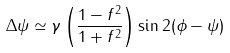Convert formula to latex. <formula><loc_0><loc_0><loc_500><loc_500>\Delta \psi \simeq \gamma \left ( \frac { 1 - f ^ { 2 } } { 1 + f ^ { 2 } } \right ) \sin 2 ( \phi - \psi )</formula> 